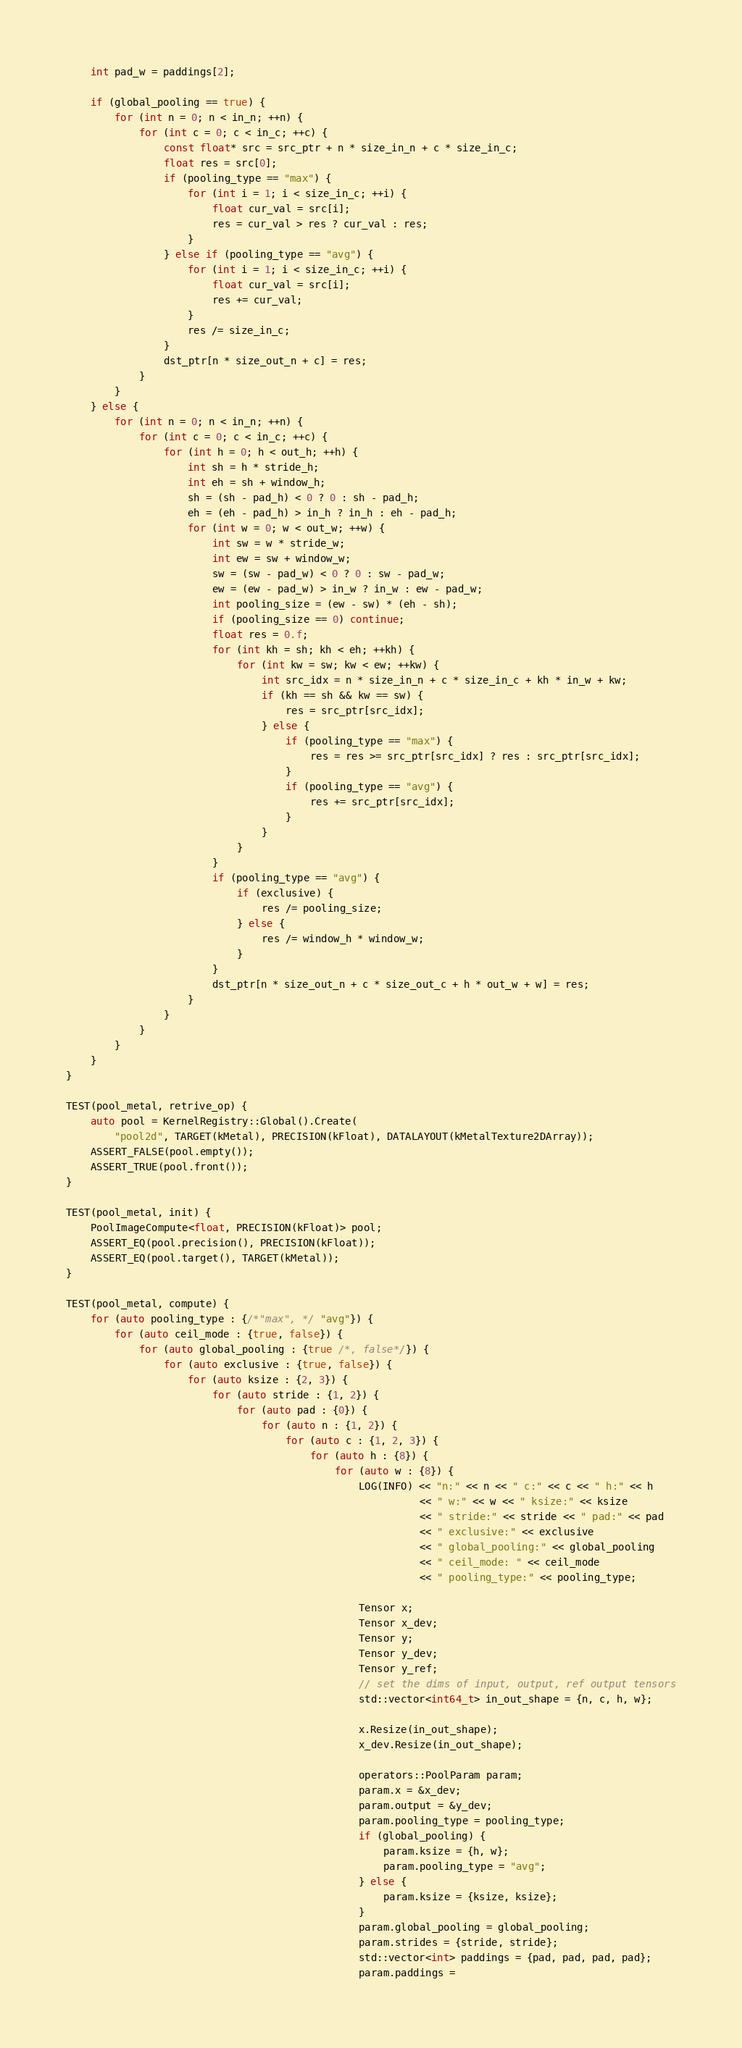Convert code to text. <code><loc_0><loc_0><loc_500><loc_500><_ObjectiveC_>    int pad_w = paddings[2];

    if (global_pooling == true) {
        for (int n = 0; n < in_n; ++n) {
            for (int c = 0; c < in_c; ++c) {
                const float* src = src_ptr + n * size_in_n + c * size_in_c;
                float res = src[0];
                if (pooling_type == "max") {
                    for (int i = 1; i < size_in_c; ++i) {
                        float cur_val = src[i];
                        res = cur_val > res ? cur_val : res;
                    }
                } else if (pooling_type == "avg") {
                    for (int i = 1; i < size_in_c; ++i) {
                        float cur_val = src[i];
                        res += cur_val;
                    }
                    res /= size_in_c;
                }
                dst_ptr[n * size_out_n + c] = res;
            }
        }
    } else {
        for (int n = 0; n < in_n; ++n) {
            for (int c = 0; c < in_c; ++c) {
                for (int h = 0; h < out_h; ++h) {
                    int sh = h * stride_h;
                    int eh = sh + window_h;
                    sh = (sh - pad_h) < 0 ? 0 : sh - pad_h;
                    eh = (eh - pad_h) > in_h ? in_h : eh - pad_h;
                    for (int w = 0; w < out_w; ++w) {
                        int sw = w * stride_w;
                        int ew = sw + window_w;
                        sw = (sw - pad_w) < 0 ? 0 : sw - pad_w;
                        ew = (ew - pad_w) > in_w ? in_w : ew - pad_w;
                        int pooling_size = (ew - sw) * (eh - sh);
                        if (pooling_size == 0) continue;
                        float res = 0.f;
                        for (int kh = sh; kh < eh; ++kh) {
                            for (int kw = sw; kw < ew; ++kw) {
                                int src_idx = n * size_in_n + c * size_in_c + kh * in_w + kw;
                                if (kh == sh && kw == sw) {
                                    res = src_ptr[src_idx];
                                } else {
                                    if (pooling_type == "max") {
                                        res = res >= src_ptr[src_idx] ? res : src_ptr[src_idx];
                                    }
                                    if (pooling_type == "avg") {
                                        res += src_ptr[src_idx];
                                    }
                                }
                            }
                        }
                        if (pooling_type == "avg") {
                            if (exclusive) {
                                res /= pooling_size;
                            } else {
                                res /= window_h * window_w;
                            }
                        }
                        dst_ptr[n * size_out_n + c * size_out_c + h * out_w + w] = res;
                    }
                }
            }
        }
    }
}

TEST(pool_metal, retrive_op) {
    auto pool = KernelRegistry::Global().Create(
        "pool2d", TARGET(kMetal), PRECISION(kFloat), DATALAYOUT(kMetalTexture2DArray));
    ASSERT_FALSE(pool.empty());
    ASSERT_TRUE(pool.front());
}

TEST(pool_metal, init) {
    PoolImageCompute<float, PRECISION(kFloat)> pool;
    ASSERT_EQ(pool.precision(), PRECISION(kFloat));
    ASSERT_EQ(pool.target(), TARGET(kMetal));
}

TEST(pool_metal, compute) {
    for (auto pooling_type : {/*"max", */ "avg"}) {
        for (auto ceil_mode : {true, false}) {
            for (auto global_pooling : {true /*, false*/}) {
                for (auto exclusive : {true, false}) {
                    for (auto ksize : {2, 3}) {
                        for (auto stride : {1, 2}) {
                            for (auto pad : {0}) {
                                for (auto n : {1, 2}) {
                                    for (auto c : {1, 2, 3}) {
                                        for (auto h : {8}) {
                                            for (auto w : {8}) {
                                                LOG(INFO) << "n:" << n << " c:" << c << " h:" << h
                                                          << " w:" << w << " ksize:" << ksize
                                                          << " stride:" << stride << " pad:" << pad
                                                          << " exclusive:" << exclusive
                                                          << " global_pooling:" << global_pooling
                                                          << " ceil_mode: " << ceil_mode
                                                          << " pooling_type:" << pooling_type;

                                                Tensor x;
                                                Tensor x_dev;
                                                Tensor y;
                                                Tensor y_dev;
                                                Tensor y_ref;
                                                // set the dims of input, output, ref output tensors
                                                std::vector<int64_t> in_out_shape = {n, c, h, w};

                                                x.Resize(in_out_shape);
                                                x_dev.Resize(in_out_shape);

                                                operators::PoolParam param;
                                                param.x = &x_dev;
                                                param.output = &y_dev;
                                                param.pooling_type = pooling_type;
                                                if (global_pooling) {
                                                    param.ksize = {h, w};
                                                    param.pooling_type = "avg";
                                                } else {
                                                    param.ksize = {ksize, ksize};
                                                }
                                                param.global_pooling = global_pooling;
                                                param.strides = {stride, stride};
                                                std::vector<int> paddings = {pad, pad, pad, pad};
                                                param.paddings =</code> 